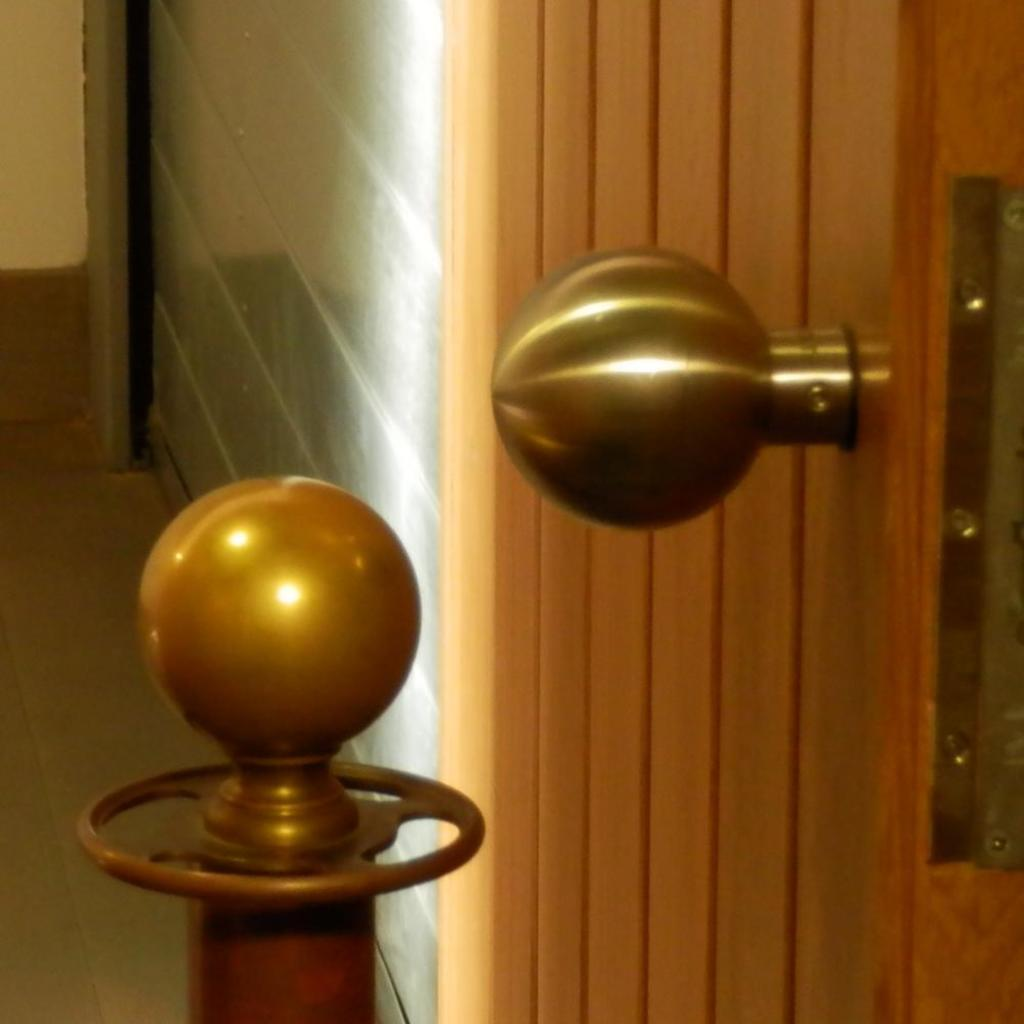What type of door is visible in the image? There is a wooden door in the image. What feature can be seen on the wooden door? The wooden door has a knob. What other object is present in the image? There is a metal rod in the image. What can be seen in the background of the image? There is a wall in the background of the image. Can you see a pear hanging from the wooden door in the image? No, there is no pear present in the image. 